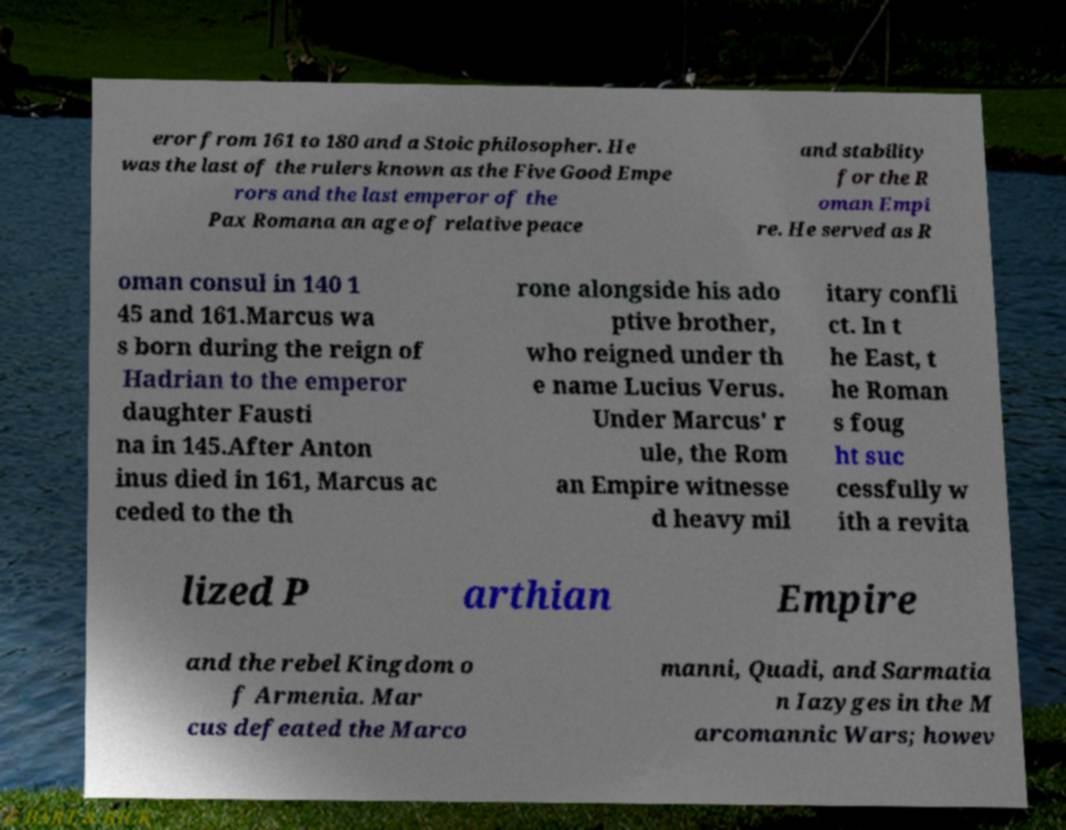Could you assist in decoding the text presented in this image and type it out clearly? eror from 161 to 180 and a Stoic philosopher. He was the last of the rulers known as the Five Good Empe rors and the last emperor of the Pax Romana an age of relative peace and stability for the R oman Empi re. He served as R oman consul in 140 1 45 and 161.Marcus wa s born during the reign of Hadrian to the emperor daughter Fausti na in 145.After Anton inus died in 161, Marcus ac ceded to the th rone alongside his ado ptive brother, who reigned under th e name Lucius Verus. Under Marcus' r ule, the Rom an Empire witnesse d heavy mil itary confli ct. In t he East, t he Roman s foug ht suc cessfully w ith a revita lized P arthian Empire and the rebel Kingdom o f Armenia. Mar cus defeated the Marco manni, Quadi, and Sarmatia n Iazyges in the M arcomannic Wars; howev 